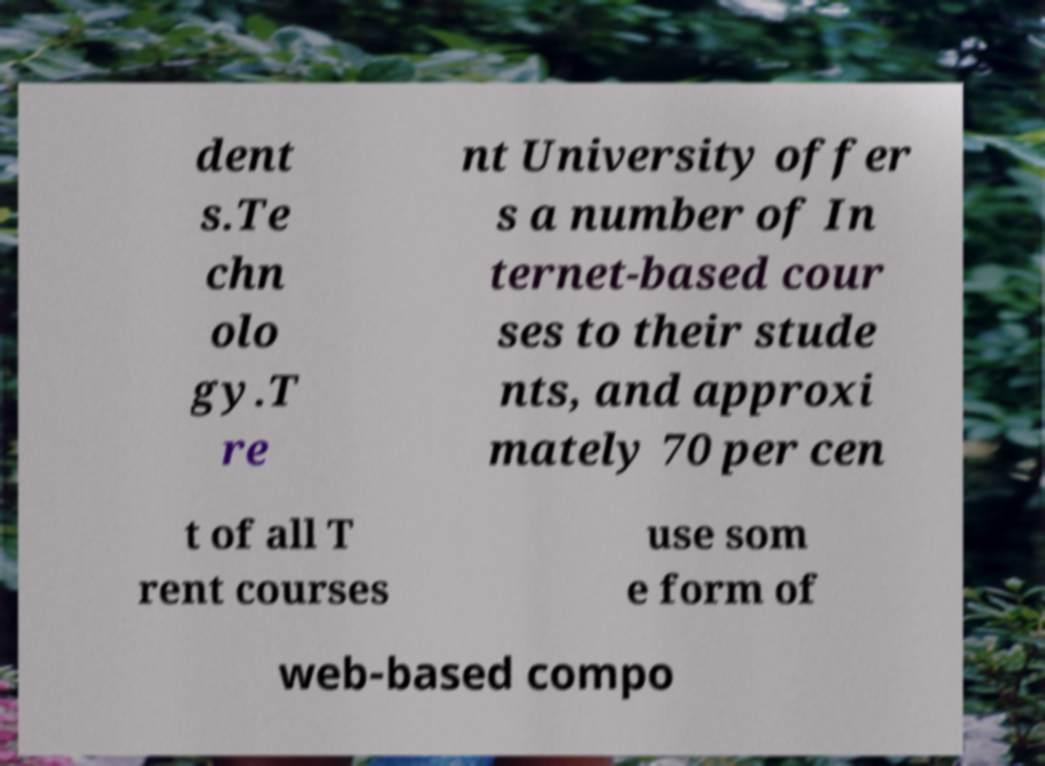Can you accurately transcribe the text from the provided image for me? dent s.Te chn olo gy.T re nt University offer s a number of In ternet-based cour ses to their stude nts, and approxi mately 70 per cen t of all T rent courses use som e form of web-based compo 